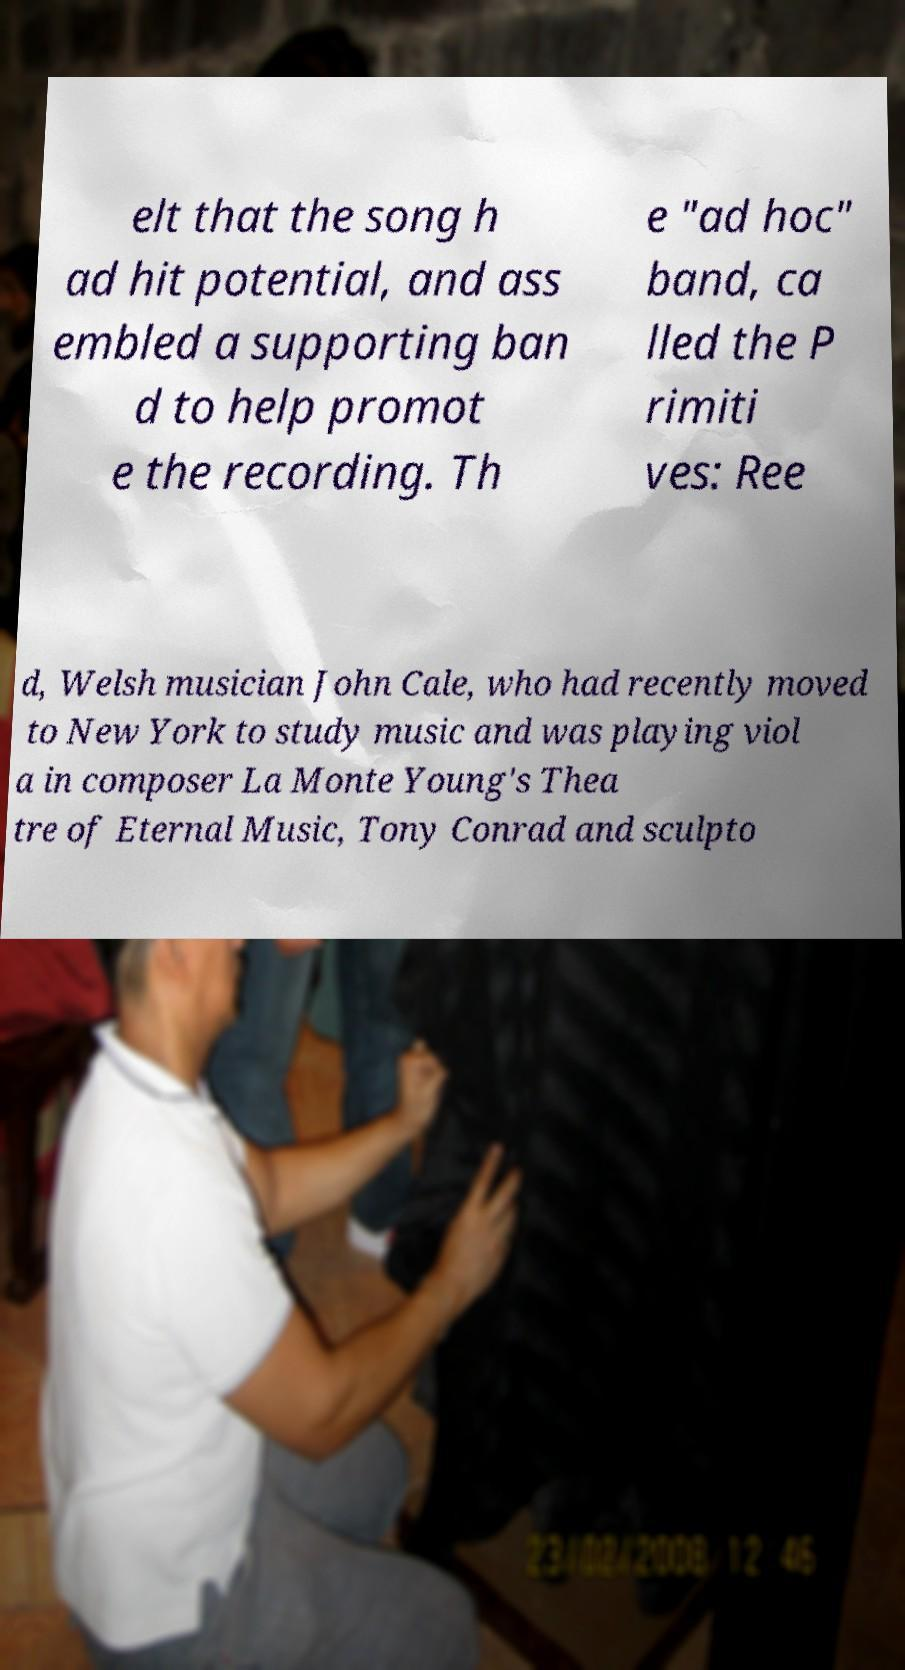What messages or text are displayed in this image? I need them in a readable, typed format. elt that the song h ad hit potential, and ass embled a supporting ban d to help promot e the recording. Th e "ad hoc" band, ca lled the P rimiti ves: Ree d, Welsh musician John Cale, who had recently moved to New York to study music and was playing viol a in composer La Monte Young's Thea tre of Eternal Music, Tony Conrad and sculpto 